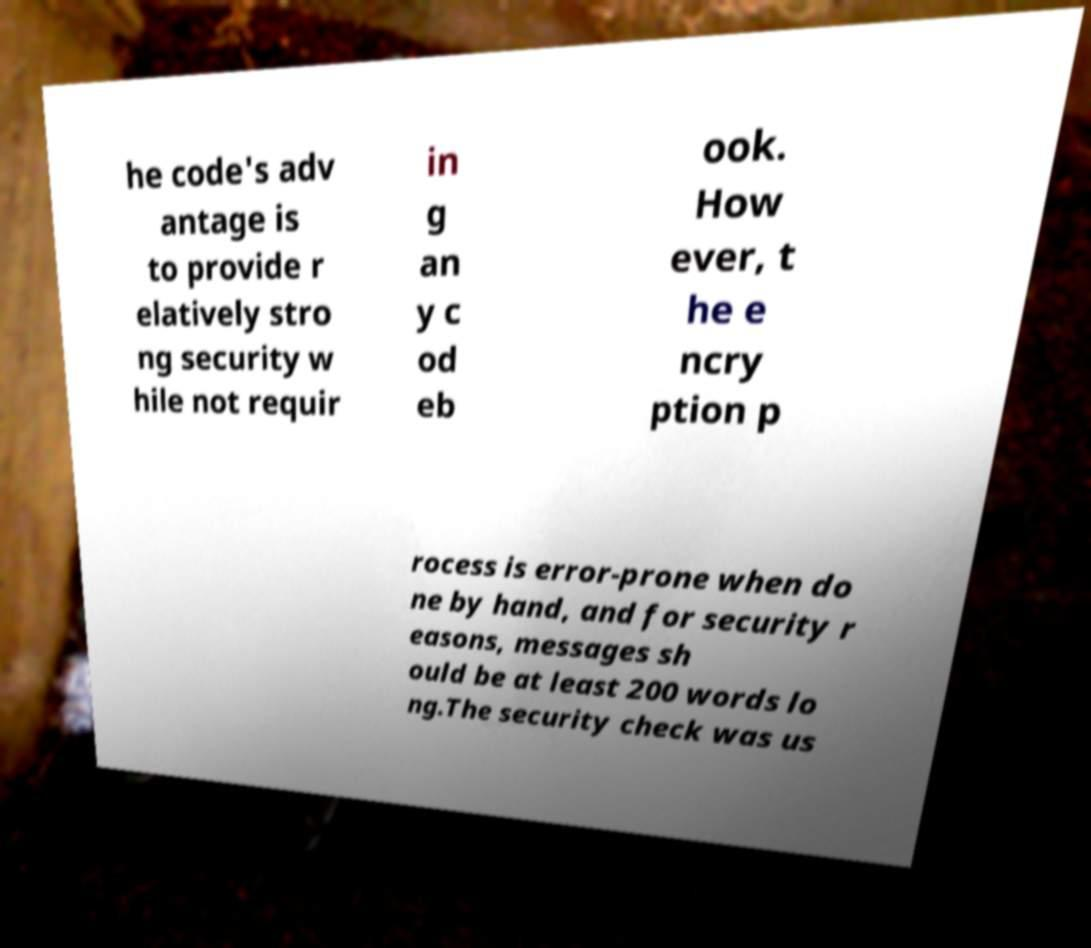What messages or text are displayed in this image? I need them in a readable, typed format. he code's adv antage is to provide r elatively stro ng security w hile not requir in g an y c od eb ook. How ever, t he e ncry ption p rocess is error-prone when do ne by hand, and for security r easons, messages sh ould be at least 200 words lo ng.The security check was us 